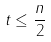Convert formula to latex. <formula><loc_0><loc_0><loc_500><loc_500>t \leq \frac { n } { 2 }</formula> 